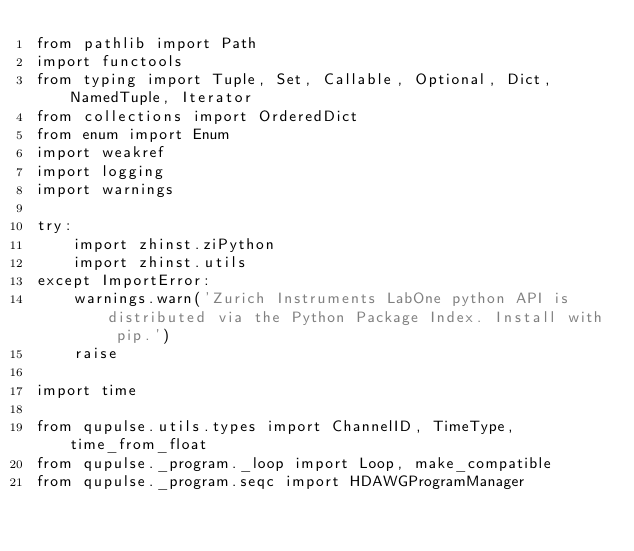<code> <loc_0><loc_0><loc_500><loc_500><_Python_>from pathlib import Path
import functools
from typing import Tuple, Set, Callable, Optional, Dict, NamedTuple, Iterator
from collections import OrderedDict
from enum import Enum
import weakref
import logging
import warnings

try:
    import zhinst.ziPython
    import zhinst.utils
except ImportError:
    warnings.warn('Zurich Instruments LabOne python API is distributed via the Python Package Index. Install with pip.')
    raise

import time

from qupulse.utils.types import ChannelID, TimeType, time_from_float
from qupulse._program._loop import Loop, make_compatible
from qupulse._program.seqc import HDAWGProgramManager</code> 